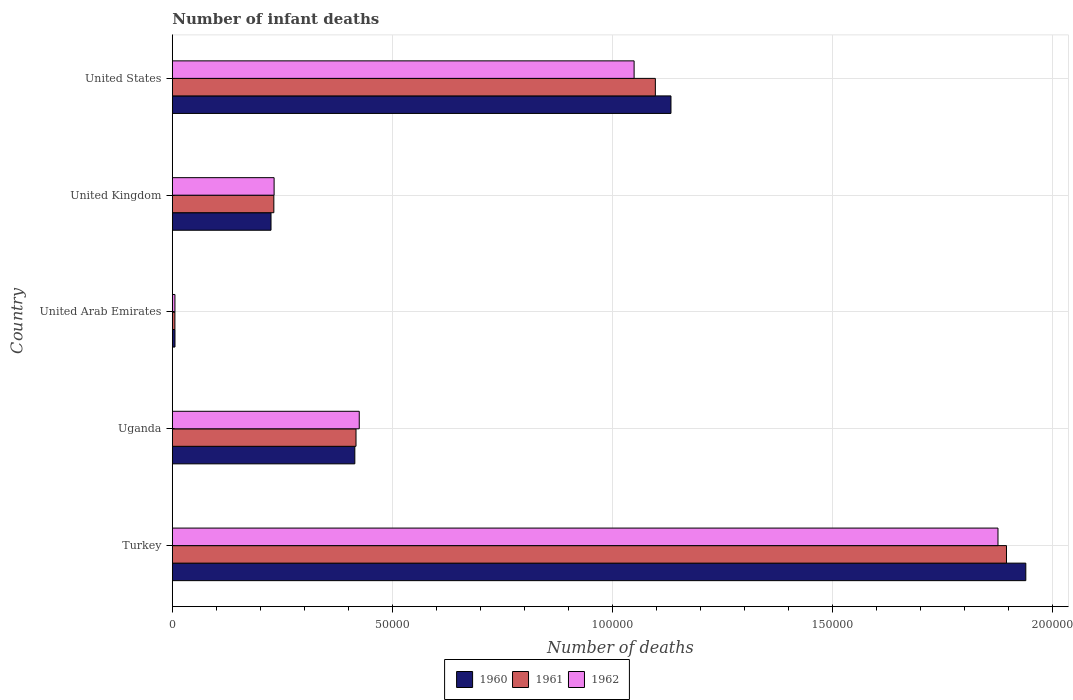How many different coloured bars are there?
Provide a short and direct response. 3. How many groups of bars are there?
Keep it short and to the point. 5. Are the number of bars on each tick of the Y-axis equal?
Your answer should be compact. Yes. What is the label of the 5th group of bars from the top?
Keep it short and to the point. Turkey. In how many cases, is the number of bars for a given country not equal to the number of legend labels?
Ensure brevity in your answer.  0. What is the number of infant deaths in 1960 in United Arab Emirates?
Offer a terse response. 598. Across all countries, what is the maximum number of infant deaths in 1961?
Your answer should be compact. 1.90e+05. Across all countries, what is the minimum number of infant deaths in 1962?
Your response must be concise. 587. In which country was the number of infant deaths in 1961 maximum?
Your response must be concise. Turkey. In which country was the number of infant deaths in 1961 minimum?
Offer a terse response. United Arab Emirates. What is the total number of infant deaths in 1961 in the graph?
Provide a succinct answer. 3.65e+05. What is the difference between the number of infant deaths in 1962 in Uganda and that in United States?
Offer a terse response. -6.25e+04. What is the difference between the number of infant deaths in 1960 in United Kingdom and the number of infant deaths in 1962 in Turkey?
Ensure brevity in your answer.  -1.65e+05. What is the average number of infant deaths in 1960 per country?
Give a very brief answer. 7.44e+04. What is the difference between the number of infant deaths in 1961 and number of infant deaths in 1960 in United Kingdom?
Your answer should be very brief. 642. What is the ratio of the number of infant deaths in 1962 in Uganda to that in United Arab Emirates?
Your answer should be very brief. 72.38. What is the difference between the highest and the second highest number of infant deaths in 1960?
Provide a short and direct response. 8.07e+04. What is the difference between the highest and the lowest number of infant deaths in 1962?
Ensure brevity in your answer.  1.87e+05. What does the 3rd bar from the top in United Kingdom represents?
Your answer should be very brief. 1960. What does the 1st bar from the bottom in United Arab Emirates represents?
Your response must be concise. 1960. Is it the case that in every country, the sum of the number of infant deaths in 1962 and number of infant deaths in 1961 is greater than the number of infant deaths in 1960?
Offer a terse response. Yes. How many bars are there?
Your answer should be compact. 15. How many countries are there in the graph?
Offer a very short reply. 5. What is the difference between two consecutive major ticks on the X-axis?
Your answer should be very brief. 5.00e+04. Are the values on the major ticks of X-axis written in scientific E-notation?
Your answer should be compact. No. Does the graph contain any zero values?
Your response must be concise. No. Does the graph contain grids?
Make the answer very short. Yes. Where does the legend appear in the graph?
Offer a very short reply. Bottom center. How many legend labels are there?
Your response must be concise. 3. What is the title of the graph?
Provide a short and direct response. Number of infant deaths. Does "2003" appear as one of the legend labels in the graph?
Your response must be concise. No. What is the label or title of the X-axis?
Offer a very short reply. Number of deaths. What is the label or title of the Y-axis?
Keep it short and to the point. Country. What is the Number of deaths of 1960 in Turkey?
Offer a very short reply. 1.94e+05. What is the Number of deaths in 1961 in Turkey?
Your answer should be very brief. 1.90e+05. What is the Number of deaths in 1962 in Turkey?
Provide a succinct answer. 1.88e+05. What is the Number of deaths in 1960 in Uganda?
Ensure brevity in your answer.  4.15e+04. What is the Number of deaths in 1961 in Uganda?
Make the answer very short. 4.18e+04. What is the Number of deaths of 1962 in Uganda?
Your answer should be compact. 4.25e+04. What is the Number of deaths in 1960 in United Arab Emirates?
Provide a succinct answer. 598. What is the Number of deaths in 1961 in United Arab Emirates?
Provide a short and direct response. 582. What is the Number of deaths of 1962 in United Arab Emirates?
Your answer should be compact. 587. What is the Number of deaths of 1960 in United Kingdom?
Offer a terse response. 2.24e+04. What is the Number of deaths of 1961 in United Kingdom?
Your answer should be very brief. 2.31e+04. What is the Number of deaths in 1962 in United Kingdom?
Offer a very short reply. 2.31e+04. What is the Number of deaths of 1960 in United States?
Offer a terse response. 1.13e+05. What is the Number of deaths in 1961 in United States?
Keep it short and to the point. 1.10e+05. What is the Number of deaths of 1962 in United States?
Give a very brief answer. 1.05e+05. Across all countries, what is the maximum Number of deaths of 1960?
Your answer should be compact. 1.94e+05. Across all countries, what is the maximum Number of deaths of 1961?
Your answer should be compact. 1.90e+05. Across all countries, what is the maximum Number of deaths of 1962?
Keep it short and to the point. 1.88e+05. Across all countries, what is the minimum Number of deaths in 1960?
Offer a very short reply. 598. Across all countries, what is the minimum Number of deaths in 1961?
Give a very brief answer. 582. Across all countries, what is the minimum Number of deaths of 1962?
Offer a very short reply. 587. What is the total Number of deaths of 1960 in the graph?
Provide a succinct answer. 3.72e+05. What is the total Number of deaths of 1961 in the graph?
Provide a short and direct response. 3.65e+05. What is the total Number of deaths of 1962 in the graph?
Offer a terse response. 3.59e+05. What is the difference between the Number of deaths in 1960 in Turkey and that in Uganda?
Offer a terse response. 1.53e+05. What is the difference between the Number of deaths of 1961 in Turkey and that in Uganda?
Keep it short and to the point. 1.48e+05. What is the difference between the Number of deaths in 1962 in Turkey and that in Uganda?
Keep it short and to the point. 1.45e+05. What is the difference between the Number of deaths of 1960 in Turkey and that in United Arab Emirates?
Provide a short and direct response. 1.93e+05. What is the difference between the Number of deaths in 1961 in Turkey and that in United Arab Emirates?
Give a very brief answer. 1.89e+05. What is the difference between the Number of deaths of 1962 in Turkey and that in United Arab Emirates?
Provide a short and direct response. 1.87e+05. What is the difference between the Number of deaths of 1960 in Turkey and that in United Kingdom?
Make the answer very short. 1.72e+05. What is the difference between the Number of deaths in 1961 in Turkey and that in United Kingdom?
Ensure brevity in your answer.  1.67e+05. What is the difference between the Number of deaths in 1962 in Turkey and that in United Kingdom?
Offer a terse response. 1.65e+05. What is the difference between the Number of deaths in 1960 in Turkey and that in United States?
Provide a succinct answer. 8.07e+04. What is the difference between the Number of deaths of 1961 in Turkey and that in United States?
Make the answer very short. 7.98e+04. What is the difference between the Number of deaths in 1962 in Turkey and that in United States?
Your answer should be very brief. 8.27e+04. What is the difference between the Number of deaths of 1960 in Uganda and that in United Arab Emirates?
Provide a succinct answer. 4.09e+04. What is the difference between the Number of deaths in 1961 in Uganda and that in United Arab Emirates?
Your answer should be very brief. 4.12e+04. What is the difference between the Number of deaths in 1962 in Uganda and that in United Arab Emirates?
Ensure brevity in your answer.  4.19e+04. What is the difference between the Number of deaths in 1960 in Uganda and that in United Kingdom?
Your answer should be very brief. 1.91e+04. What is the difference between the Number of deaths in 1961 in Uganda and that in United Kingdom?
Keep it short and to the point. 1.87e+04. What is the difference between the Number of deaths of 1962 in Uganda and that in United Kingdom?
Keep it short and to the point. 1.94e+04. What is the difference between the Number of deaths of 1960 in Uganda and that in United States?
Keep it short and to the point. -7.19e+04. What is the difference between the Number of deaths in 1961 in Uganda and that in United States?
Your response must be concise. -6.81e+04. What is the difference between the Number of deaths in 1962 in Uganda and that in United States?
Provide a short and direct response. -6.25e+04. What is the difference between the Number of deaths of 1960 in United Arab Emirates and that in United Kingdom?
Provide a succinct answer. -2.18e+04. What is the difference between the Number of deaths in 1961 in United Arab Emirates and that in United Kingdom?
Provide a succinct answer. -2.25e+04. What is the difference between the Number of deaths in 1962 in United Arab Emirates and that in United Kingdom?
Offer a very short reply. -2.25e+04. What is the difference between the Number of deaths in 1960 in United Arab Emirates and that in United States?
Your answer should be very brief. -1.13e+05. What is the difference between the Number of deaths in 1961 in United Arab Emirates and that in United States?
Ensure brevity in your answer.  -1.09e+05. What is the difference between the Number of deaths of 1962 in United Arab Emirates and that in United States?
Keep it short and to the point. -1.04e+05. What is the difference between the Number of deaths of 1960 in United Kingdom and that in United States?
Provide a succinct answer. -9.09e+04. What is the difference between the Number of deaths of 1961 in United Kingdom and that in United States?
Make the answer very short. -8.67e+04. What is the difference between the Number of deaths in 1962 in United Kingdom and that in United States?
Give a very brief answer. -8.18e+04. What is the difference between the Number of deaths of 1960 in Turkey and the Number of deaths of 1961 in Uganda?
Your answer should be very brief. 1.52e+05. What is the difference between the Number of deaths in 1960 in Turkey and the Number of deaths in 1962 in Uganda?
Your response must be concise. 1.52e+05. What is the difference between the Number of deaths of 1961 in Turkey and the Number of deaths of 1962 in Uganda?
Your response must be concise. 1.47e+05. What is the difference between the Number of deaths in 1960 in Turkey and the Number of deaths in 1961 in United Arab Emirates?
Your answer should be compact. 1.93e+05. What is the difference between the Number of deaths of 1960 in Turkey and the Number of deaths of 1962 in United Arab Emirates?
Provide a short and direct response. 1.93e+05. What is the difference between the Number of deaths of 1961 in Turkey and the Number of deaths of 1962 in United Arab Emirates?
Provide a succinct answer. 1.89e+05. What is the difference between the Number of deaths of 1960 in Turkey and the Number of deaths of 1961 in United Kingdom?
Ensure brevity in your answer.  1.71e+05. What is the difference between the Number of deaths of 1960 in Turkey and the Number of deaths of 1962 in United Kingdom?
Provide a succinct answer. 1.71e+05. What is the difference between the Number of deaths in 1961 in Turkey and the Number of deaths in 1962 in United Kingdom?
Ensure brevity in your answer.  1.66e+05. What is the difference between the Number of deaths in 1960 in Turkey and the Number of deaths in 1961 in United States?
Keep it short and to the point. 8.42e+04. What is the difference between the Number of deaths of 1960 in Turkey and the Number of deaths of 1962 in United States?
Offer a very short reply. 8.90e+04. What is the difference between the Number of deaths of 1961 in Turkey and the Number of deaths of 1962 in United States?
Offer a terse response. 8.47e+04. What is the difference between the Number of deaths of 1960 in Uganda and the Number of deaths of 1961 in United Arab Emirates?
Your answer should be compact. 4.09e+04. What is the difference between the Number of deaths of 1960 in Uganda and the Number of deaths of 1962 in United Arab Emirates?
Your answer should be very brief. 4.09e+04. What is the difference between the Number of deaths of 1961 in Uganda and the Number of deaths of 1962 in United Arab Emirates?
Keep it short and to the point. 4.12e+04. What is the difference between the Number of deaths in 1960 in Uganda and the Number of deaths in 1961 in United Kingdom?
Provide a succinct answer. 1.84e+04. What is the difference between the Number of deaths in 1960 in Uganda and the Number of deaths in 1962 in United Kingdom?
Make the answer very short. 1.84e+04. What is the difference between the Number of deaths of 1961 in Uganda and the Number of deaths of 1962 in United Kingdom?
Offer a terse response. 1.86e+04. What is the difference between the Number of deaths of 1960 in Uganda and the Number of deaths of 1961 in United States?
Offer a very short reply. -6.83e+04. What is the difference between the Number of deaths in 1960 in Uganda and the Number of deaths in 1962 in United States?
Offer a terse response. -6.35e+04. What is the difference between the Number of deaths of 1961 in Uganda and the Number of deaths of 1962 in United States?
Provide a succinct answer. -6.32e+04. What is the difference between the Number of deaths in 1960 in United Arab Emirates and the Number of deaths in 1961 in United Kingdom?
Provide a short and direct response. -2.25e+04. What is the difference between the Number of deaths in 1960 in United Arab Emirates and the Number of deaths in 1962 in United Kingdom?
Make the answer very short. -2.25e+04. What is the difference between the Number of deaths in 1961 in United Arab Emirates and the Number of deaths in 1962 in United Kingdom?
Your answer should be very brief. -2.26e+04. What is the difference between the Number of deaths in 1960 in United Arab Emirates and the Number of deaths in 1961 in United States?
Give a very brief answer. -1.09e+05. What is the difference between the Number of deaths in 1960 in United Arab Emirates and the Number of deaths in 1962 in United States?
Your answer should be compact. -1.04e+05. What is the difference between the Number of deaths of 1961 in United Arab Emirates and the Number of deaths of 1962 in United States?
Ensure brevity in your answer.  -1.04e+05. What is the difference between the Number of deaths of 1960 in United Kingdom and the Number of deaths of 1961 in United States?
Offer a terse response. -8.74e+04. What is the difference between the Number of deaths of 1960 in United Kingdom and the Number of deaths of 1962 in United States?
Make the answer very short. -8.25e+04. What is the difference between the Number of deaths of 1961 in United Kingdom and the Number of deaths of 1962 in United States?
Your answer should be very brief. -8.19e+04. What is the average Number of deaths of 1960 per country?
Provide a short and direct response. 7.44e+04. What is the average Number of deaths of 1961 per country?
Your answer should be very brief. 7.30e+04. What is the average Number of deaths of 1962 per country?
Provide a short and direct response. 7.18e+04. What is the difference between the Number of deaths in 1960 and Number of deaths in 1961 in Turkey?
Ensure brevity in your answer.  4395. What is the difference between the Number of deaths of 1960 and Number of deaths of 1962 in Turkey?
Provide a succinct answer. 6326. What is the difference between the Number of deaths in 1961 and Number of deaths in 1962 in Turkey?
Make the answer very short. 1931. What is the difference between the Number of deaths of 1960 and Number of deaths of 1961 in Uganda?
Offer a very short reply. -270. What is the difference between the Number of deaths in 1960 and Number of deaths in 1962 in Uganda?
Make the answer very short. -1005. What is the difference between the Number of deaths of 1961 and Number of deaths of 1962 in Uganda?
Your response must be concise. -735. What is the difference between the Number of deaths in 1960 and Number of deaths in 1961 in United Arab Emirates?
Offer a very short reply. 16. What is the difference between the Number of deaths of 1961 and Number of deaths of 1962 in United Arab Emirates?
Make the answer very short. -5. What is the difference between the Number of deaths of 1960 and Number of deaths of 1961 in United Kingdom?
Your response must be concise. -642. What is the difference between the Number of deaths of 1960 and Number of deaths of 1962 in United Kingdom?
Your response must be concise. -702. What is the difference between the Number of deaths of 1961 and Number of deaths of 1962 in United Kingdom?
Your answer should be very brief. -60. What is the difference between the Number of deaths in 1960 and Number of deaths in 1961 in United States?
Provide a succinct answer. 3550. What is the difference between the Number of deaths of 1960 and Number of deaths of 1962 in United States?
Your response must be concise. 8380. What is the difference between the Number of deaths of 1961 and Number of deaths of 1962 in United States?
Your response must be concise. 4830. What is the ratio of the Number of deaths in 1960 in Turkey to that in Uganda?
Your answer should be very brief. 4.68. What is the ratio of the Number of deaths in 1961 in Turkey to that in Uganda?
Your response must be concise. 4.54. What is the ratio of the Number of deaths of 1962 in Turkey to that in Uganda?
Ensure brevity in your answer.  4.42. What is the ratio of the Number of deaths in 1960 in Turkey to that in United Arab Emirates?
Provide a succinct answer. 324.45. What is the ratio of the Number of deaths in 1961 in Turkey to that in United Arab Emirates?
Provide a short and direct response. 325.82. What is the ratio of the Number of deaths in 1962 in Turkey to that in United Arab Emirates?
Provide a succinct answer. 319.76. What is the ratio of the Number of deaths of 1960 in Turkey to that in United Kingdom?
Offer a very short reply. 8.65. What is the ratio of the Number of deaths of 1961 in Turkey to that in United Kingdom?
Your answer should be compact. 8.22. What is the ratio of the Number of deaths in 1962 in Turkey to that in United Kingdom?
Your answer should be compact. 8.11. What is the ratio of the Number of deaths in 1960 in Turkey to that in United States?
Your response must be concise. 1.71. What is the ratio of the Number of deaths of 1961 in Turkey to that in United States?
Your answer should be very brief. 1.73. What is the ratio of the Number of deaths of 1962 in Turkey to that in United States?
Provide a short and direct response. 1.79. What is the ratio of the Number of deaths of 1960 in Uganda to that in United Arab Emirates?
Keep it short and to the point. 69.37. What is the ratio of the Number of deaths in 1961 in Uganda to that in United Arab Emirates?
Make the answer very short. 71.74. What is the ratio of the Number of deaths of 1962 in Uganda to that in United Arab Emirates?
Provide a short and direct response. 72.38. What is the ratio of the Number of deaths of 1960 in Uganda to that in United Kingdom?
Offer a very short reply. 1.85. What is the ratio of the Number of deaths in 1961 in Uganda to that in United Kingdom?
Keep it short and to the point. 1.81. What is the ratio of the Number of deaths of 1962 in Uganda to that in United Kingdom?
Offer a very short reply. 1.84. What is the ratio of the Number of deaths of 1960 in Uganda to that in United States?
Your answer should be very brief. 0.37. What is the ratio of the Number of deaths in 1961 in Uganda to that in United States?
Your answer should be compact. 0.38. What is the ratio of the Number of deaths of 1962 in Uganda to that in United States?
Offer a very short reply. 0.4. What is the ratio of the Number of deaths of 1960 in United Arab Emirates to that in United Kingdom?
Ensure brevity in your answer.  0.03. What is the ratio of the Number of deaths in 1961 in United Arab Emirates to that in United Kingdom?
Provide a succinct answer. 0.03. What is the ratio of the Number of deaths in 1962 in United Arab Emirates to that in United Kingdom?
Your answer should be very brief. 0.03. What is the ratio of the Number of deaths of 1960 in United Arab Emirates to that in United States?
Ensure brevity in your answer.  0.01. What is the ratio of the Number of deaths in 1961 in United Arab Emirates to that in United States?
Provide a short and direct response. 0.01. What is the ratio of the Number of deaths of 1962 in United Arab Emirates to that in United States?
Ensure brevity in your answer.  0.01. What is the ratio of the Number of deaths in 1960 in United Kingdom to that in United States?
Ensure brevity in your answer.  0.2. What is the ratio of the Number of deaths in 1961 in United Kingdom to that in United States?
Ensure brevity in your answer.  0.21. What is the ratio of the Number of deaths in 1962 in United Kingdom to that in United States?
Provide a short and direct response. 0.22. What is the difference between the highest and the second highest Number of deaths of 1960?
Keep it short and to the point. 8.07e+04. What is the difference between the highest and the second highest Number of deaths of 1961?
Your answer should be compact. 7.98e+04. What is the difference between the highest and the second highest Number of deaths of 1962?
Give a very brief answer. 8.27e+04. What is the difference between the highest and the lowest Number of deaths in 1960?
Offer a terse response. 1.93e+05. What is the difference between the highest and the lowest Number of deaths in 1961?
Make the answer very short. 1.89e+05. What is the difference between the highest and the lowest Number of deaths in 1962?
Make the answer very short. 1.87e+05. 